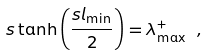Convert formula to latex. <formula><loc_0><loc_0><loc_500><loc_500>s \tanh \left ( \frac { s l _ { \min } } { 2 } \right ) = \lambda _ { \max } ^ { + } \ ,</formula> 